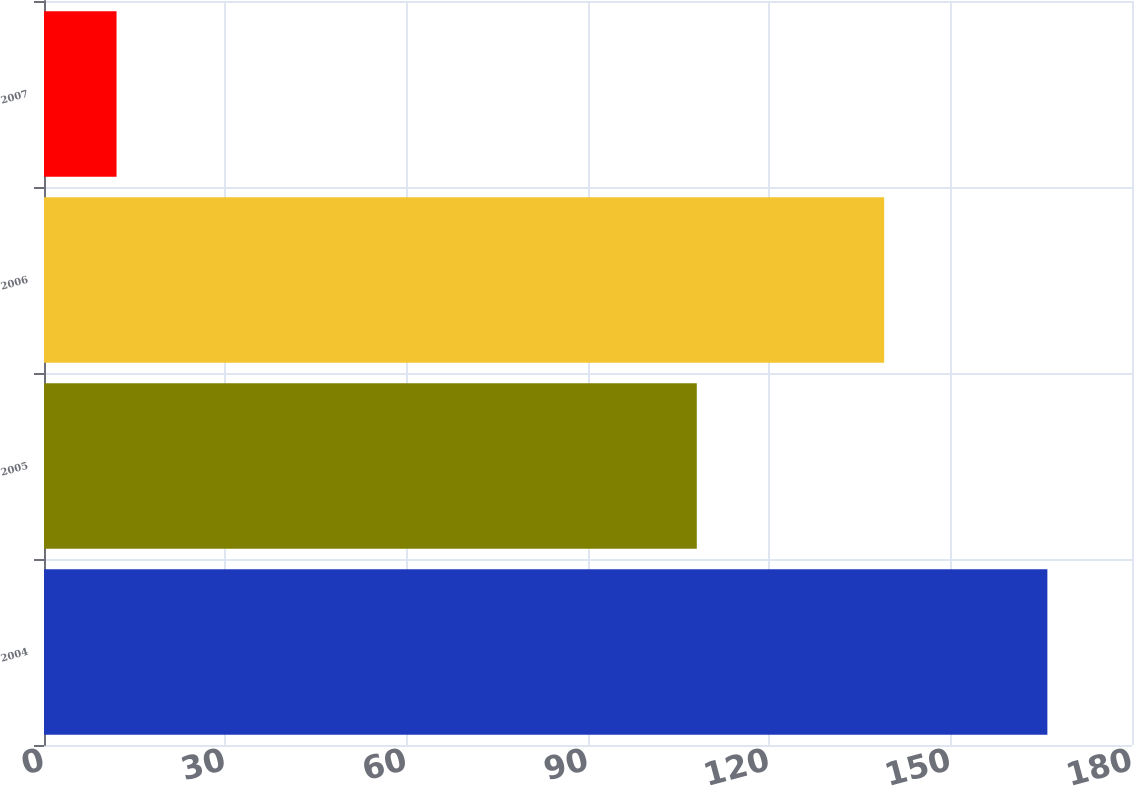Convert chart to OTSL. <chart><loc_0><loc_0><loc_500><loc_500><bar_chart><fcel>2004<fcel>2005<fcel>2006<fcel>2007<nl><fcel>166<fcel>108<fcel>139<fcel>12<nl></chart> 